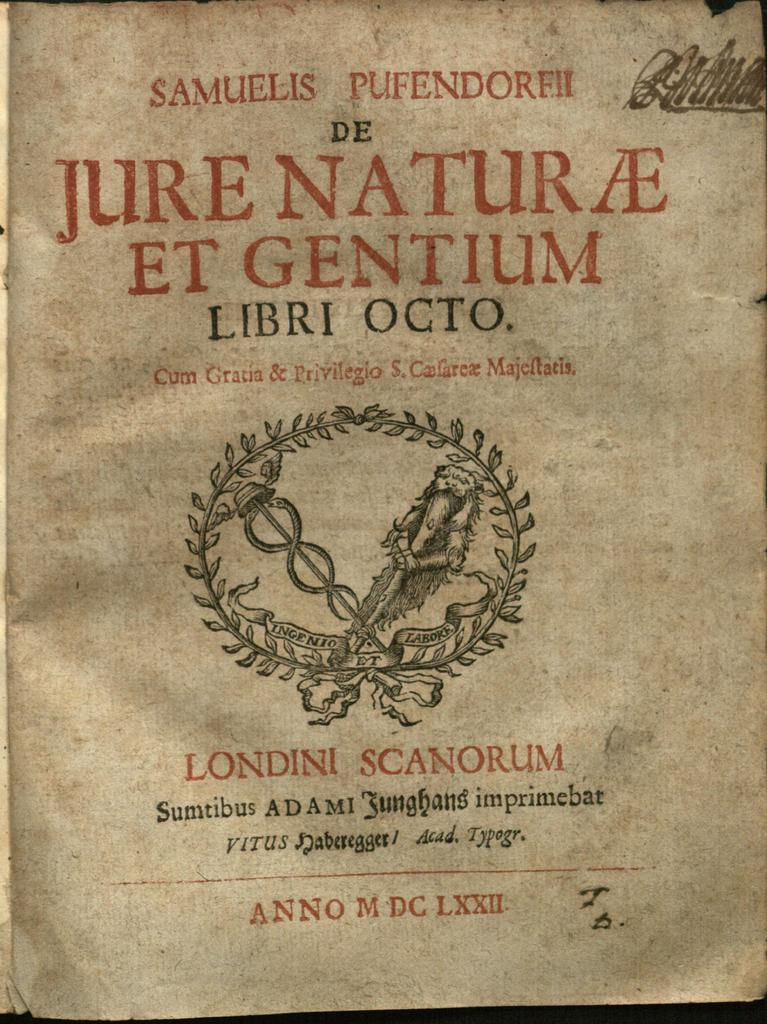What is present on the paper in the image? The paper contains text and an image in the middle. Can you describe the text on the paper? Unfortunately, the specific content of the text cannot be determined from the image. What is the main subject of the image in the middle of the paper? The main subject of the image in the middle of the paper cannot be determined from the image alone. How many hands are holding the loaf of bread in the image? There is no loaf of bread or hands present in the image. What type of horse can be seen in the image? There is no horse present in the image. 